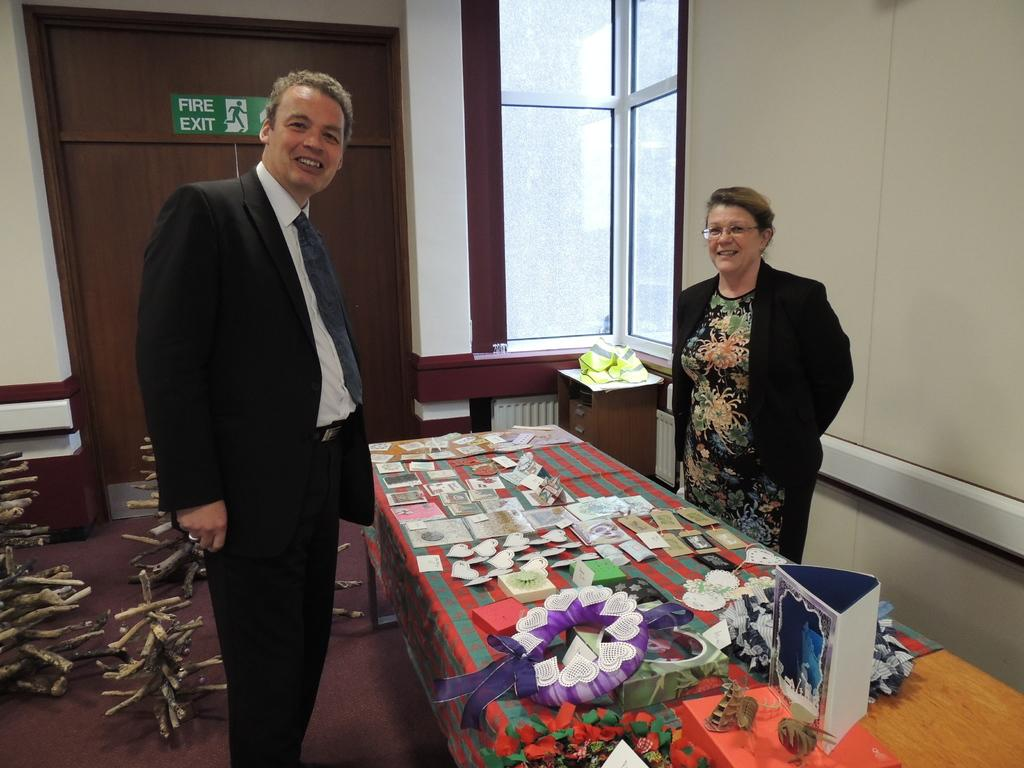Who is present in the image? There is a man and a woman in the image. What expressions do the man and woman have? Both the man and the woman are smiling in the image. What can be seen on the table in the image? There are items on a table in the image. What type of art can be seen on the playground in the image? There is no art or playground present in the image; it features a man and a woman smiling. What kind of flesh is visible on the man's arm in the image? There is no flesh visible on the man's arm in the image; it is not that detailed. 